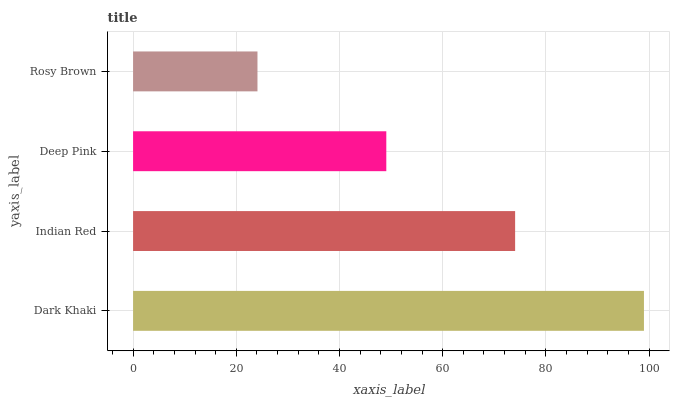Is Rosy Brown the minimum?
Answer yes or no. Yes. Is Dark Khaki the maximum?
Answer yes or no. Yes. Is Indian Red the minimum?
Answer yes or no. No. Is Indian Red the maximum?
Answer yes or no. No. Is Dark Khaki greater than Indian Red?
Answer yes or no. Yes. Is Indian Red less than Dark Khaki?
Answer yes or no. Yes. Is Indian Red greater than Dark Khaki?
Answer yes or no. No. Is Dark Khaki less than Indian Red?
Answer yes or no. No. Is Indian Red the high median?
Answer yes or no. Yes. Is Deep Pink the low median?
Answer yes or no. Yes. Is Deep Pink the high median?
Answer yes or no. No. Is Rosy Brown the low median?
Answer yes or no. No. 